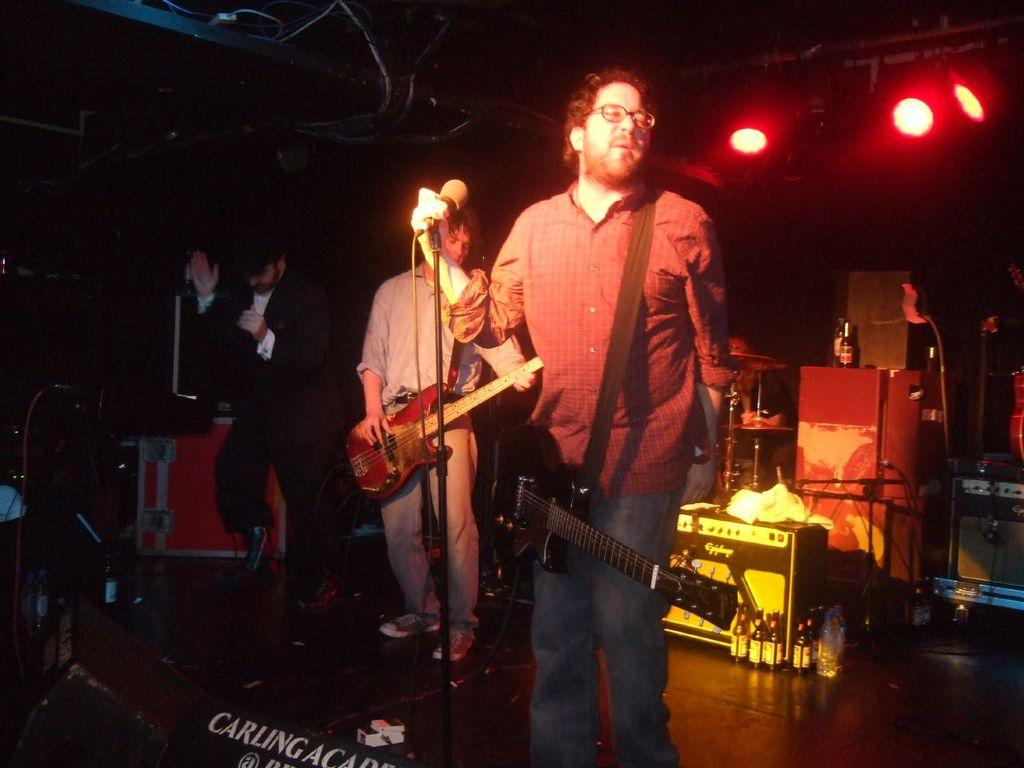How many people are on the stage in the image? There are three persons on the stage in the image. What are the three persons doing on the stage? The three persons are part of a musical band. What can be seen in the image that is used for amplifying sound? There is a microphone in the image. What is visible in the image that provides illumination? There are lights in the image. What musical instruments are the persons holding? The persons are holding guitars. What type of hydrant can be seen in the image? There is no hydrant present in the image. What is the color of the plate on the edge of the stage? There is no plate visible in the image, and the edge of the stage is not mentioned in the provided facts. 